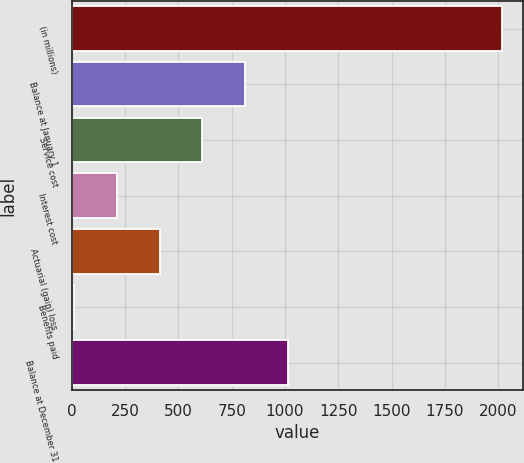<chart> <loc_0><loc_0><loc_500><loc_500><bar_chart><fcel>(in millions)<fcel>Balance at January 1<fcel>Service cost<fcel>Interest cost<fcel>Actuarial (gain) loss<fcel>Benefits paid<fcel>Balance at December 31<nl><fcel>2017<fcel>813.16<fcel>612.52<fcel>211.24<fcel>411.88<fcel>10.6<fcel>1013.8<nl></chart> 